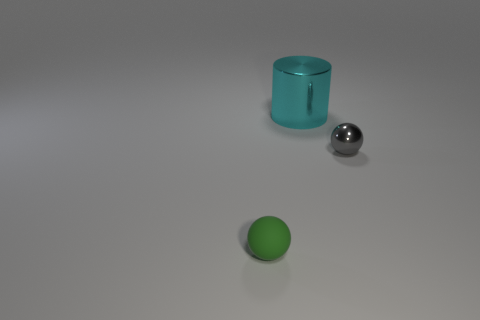What materials appear to be represented by the objects in the image? The objects seem to be made from different materials: the cyan cylinder looks to be made of a shiny, possibly reflective plastic or glass-like material, the small sphere appears to be metallic and reflective, likely simulating steel or polished chrome, and the green sphere has a matte finish that could represent rubber or a similar material. 